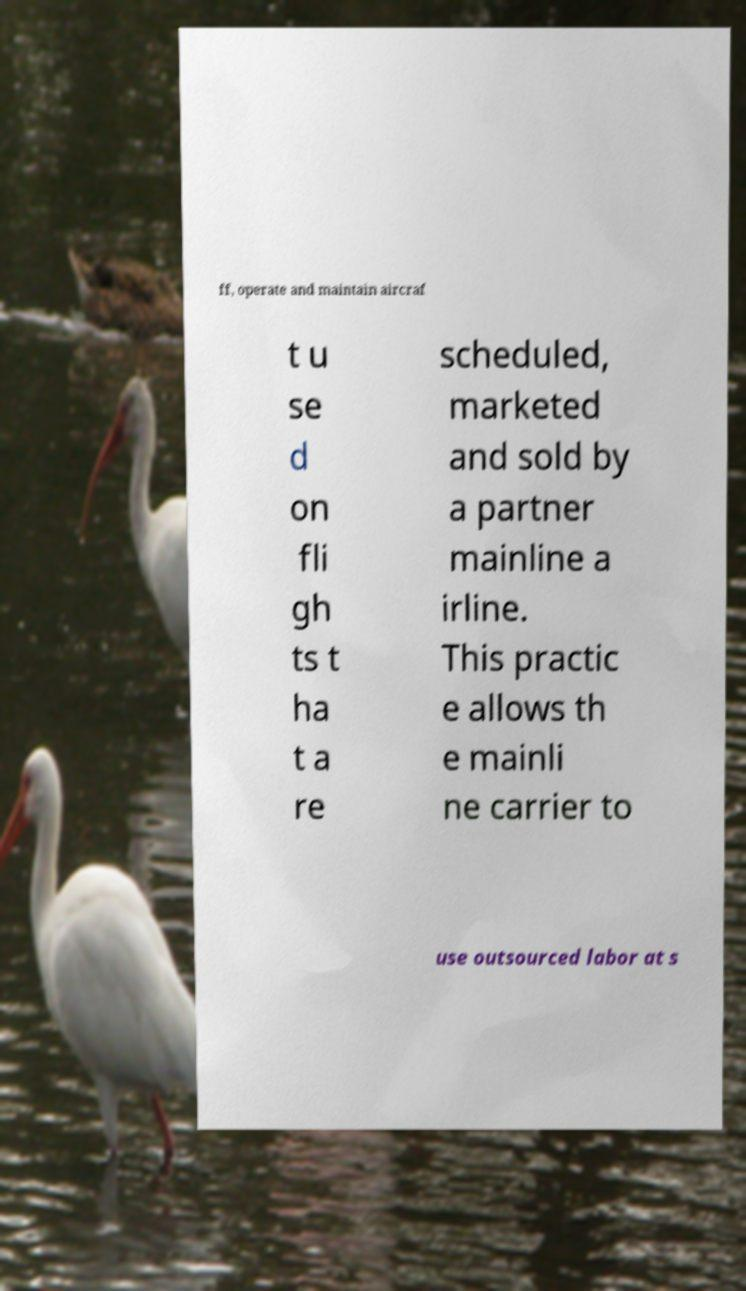Could you assist in decoding the text presented in this image and type it out clearly? ff, operate and maintain aircraf t u se d on fli gh ts t ha t a re scheduled, marketed and sold by a partner mainline a irline. This practic e allows th e mainli ne carrier to use outsourced labor at s 